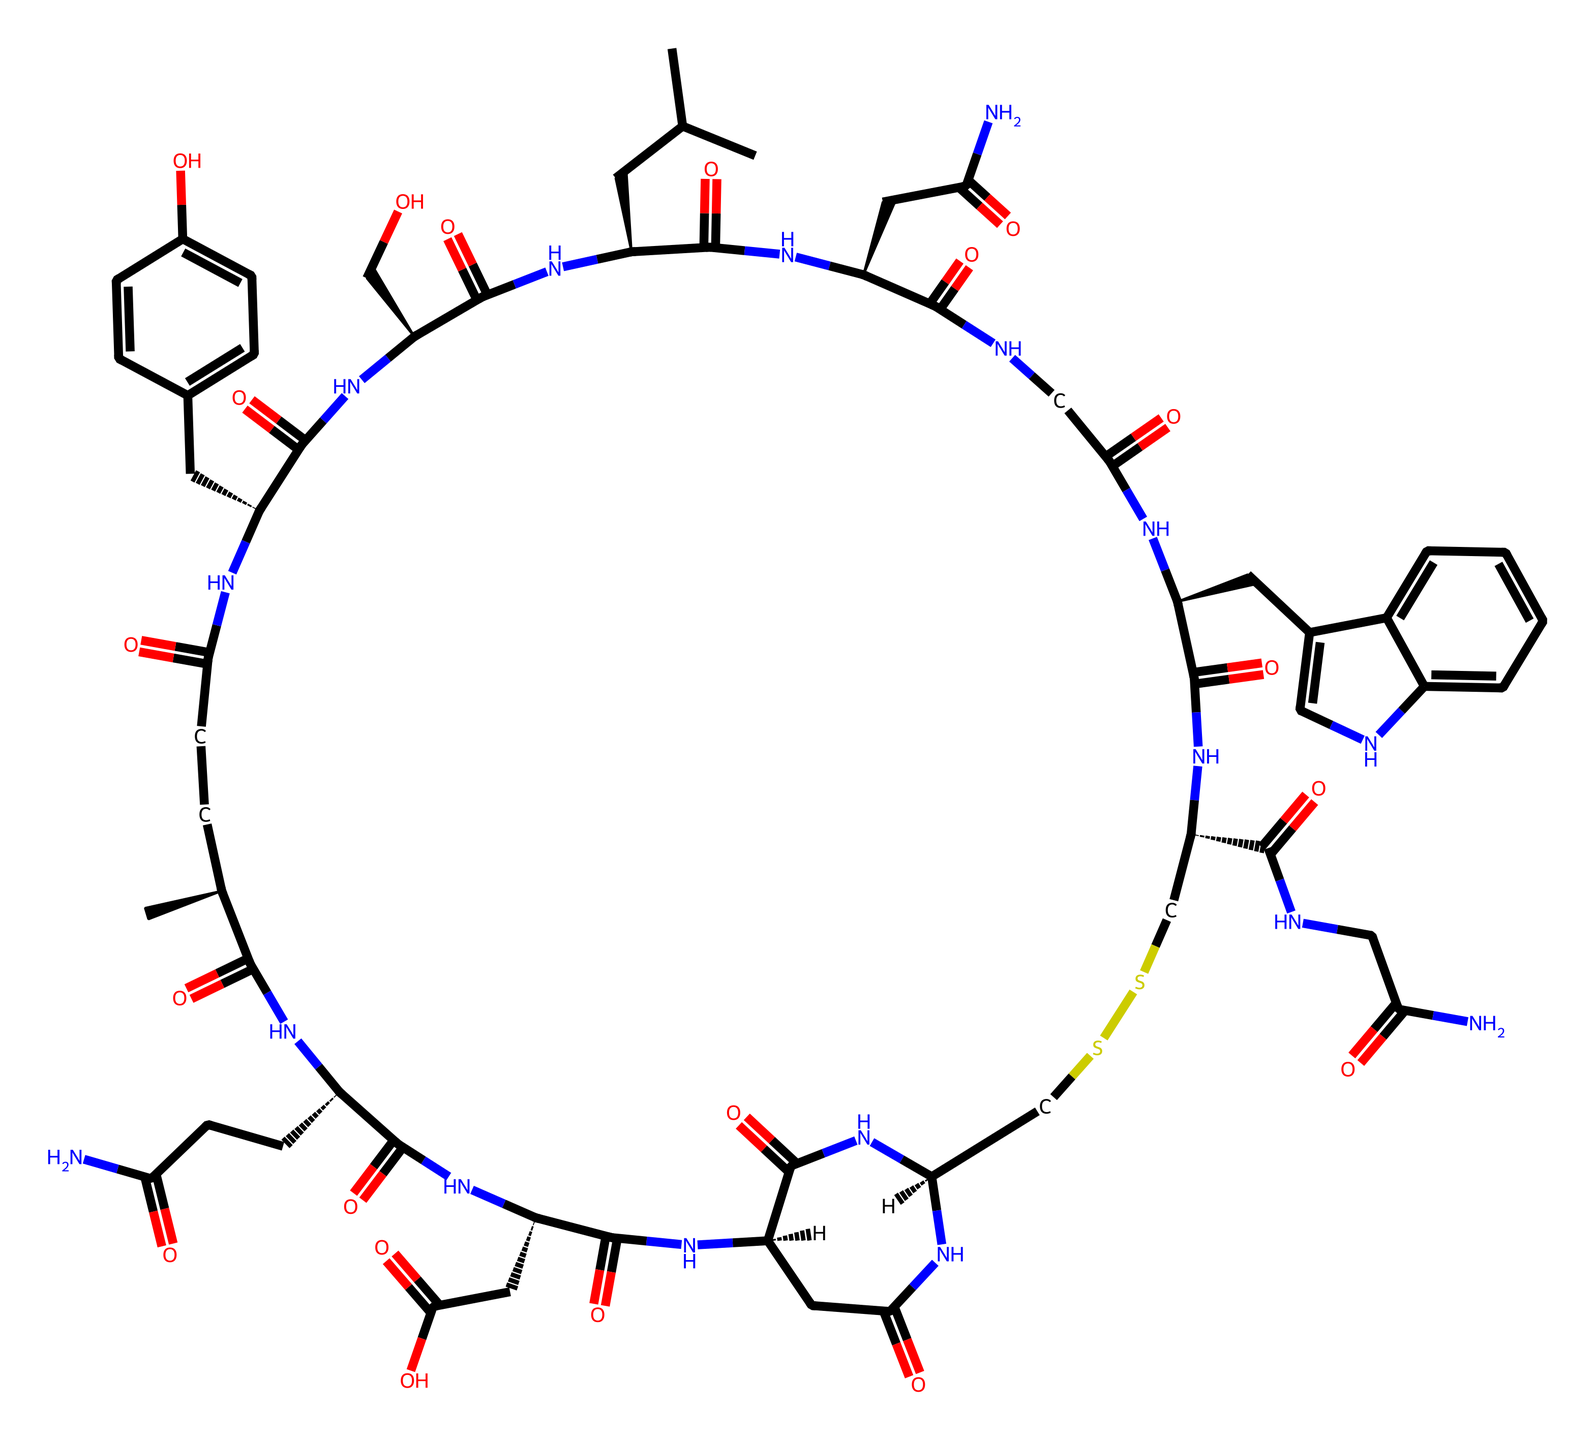What is the chemical name of this molecule? The SMILES representation indicates the structure corresponds to oxytocin, which is a known hormone.
Answer: oxytocin How many carbon atoms are present in this molecule? By analyzing the SMILES string, we can count the number of carbon (C) atoms. There are 23 carbon atoms in total in this structure.
Answer: 23 How many nitrogen atoms are in this hormone? The SMILES representation has multiple occurrences of nitrogen (N), and counting these reveals there are 5 nitrogen atoms in the structure.
Answer: 5 Which part of this molecule is responsible for its role in bonding and social interactions? Oxytocin, known as the "bonding hormone," has specific regions in its structure that facilitate interactions with receptors in the brain. This functional aspect comes from how the molecular structure connects to receptor sites.
Answer: receptor sites What type of hormone is oxytocin classified as? Oxytocin is classified as a peptide hormone based on its structure composed of amino acids interconnected by peptide bonds.
Answer: peptide hormone What functional groups are evident in the chemical structure? The structure exhibits multiple carbonyl (C=O) and amine (N-H) functional groups, which are typical in peptide hormones.
Answer: carbonyl and amine groups How does the structure of oxytocin relate to its function in teamwork? The specific arrangement of atoms and functional groups allows oxytocin to bind effectively to its receptors, thus enhancing feelings of trust and bonding. This relationship between structure and function is critical for its role in teamwork and collaboration.
Answer: binding to receptors 